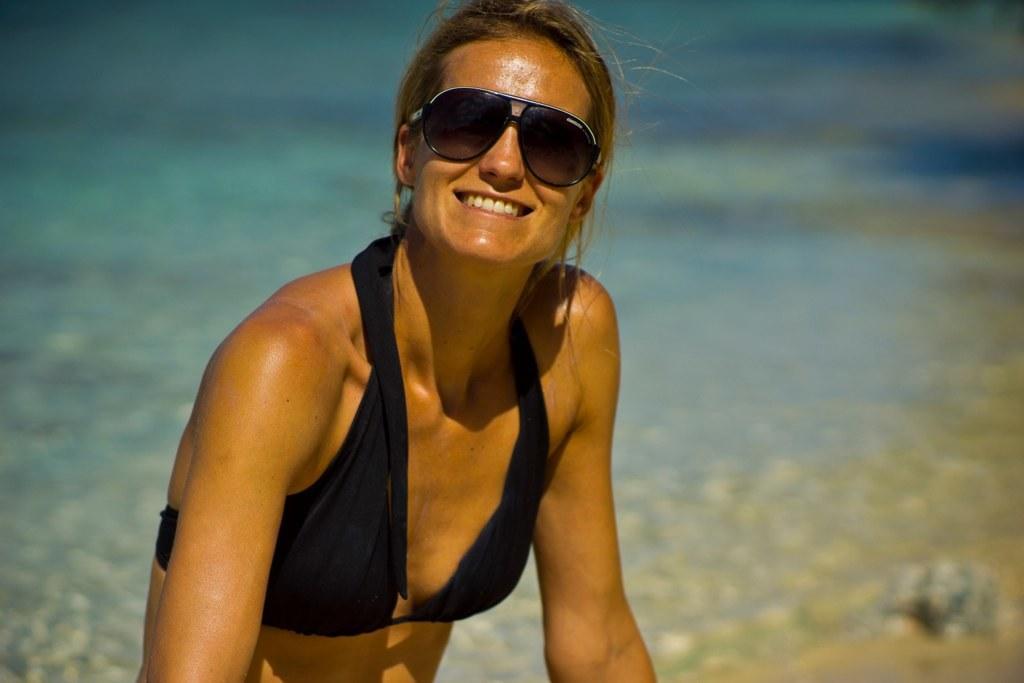Could you give a brief overview of what you see in this image? In this image I can see a woman smiling and wearing goggles. The background is blurred. 